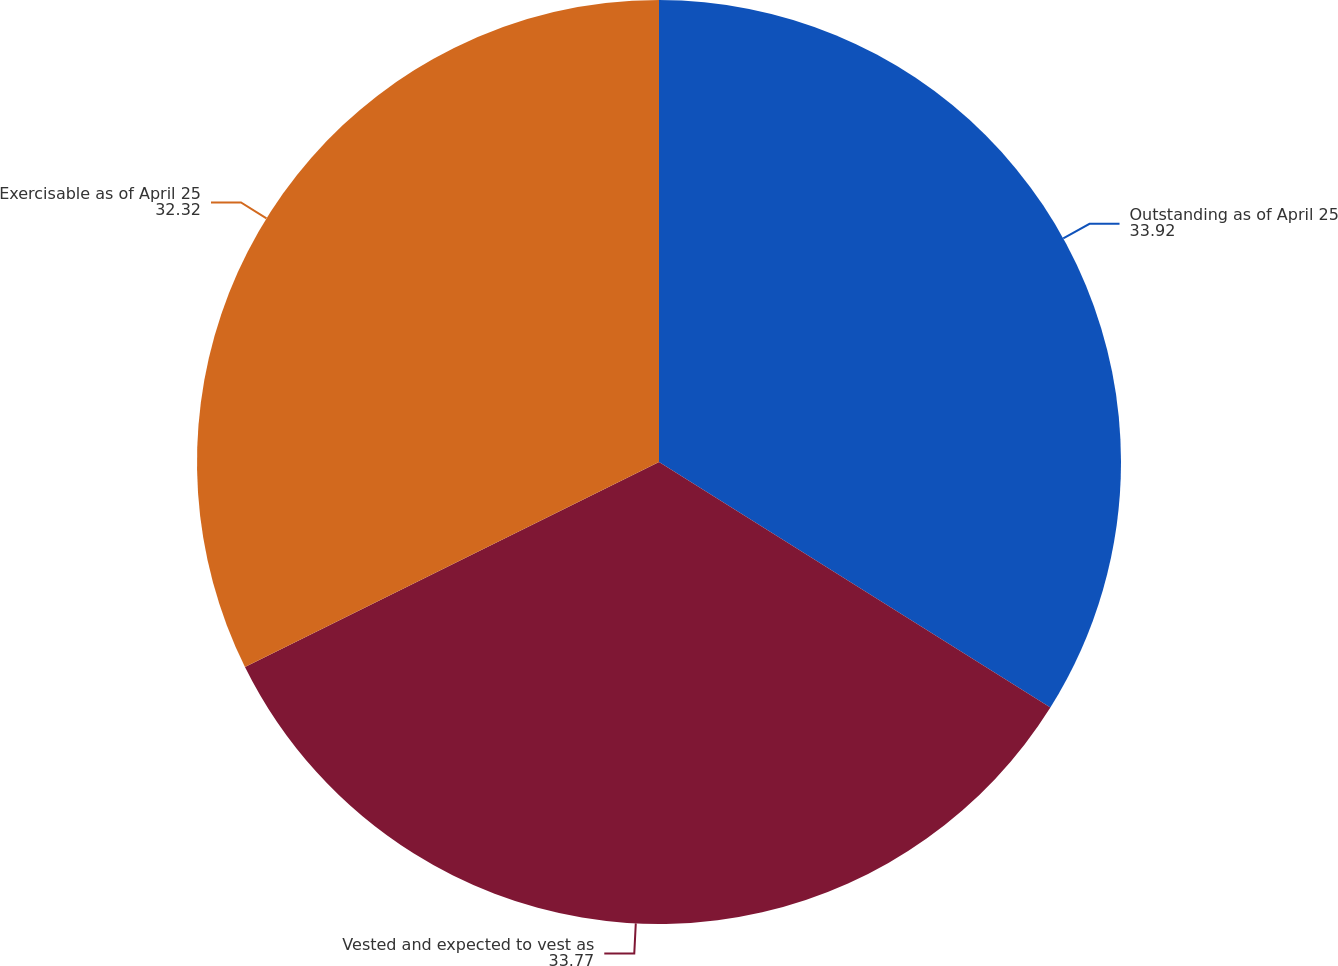Convert chart to OTSL. <chart><loc_0><loc_0><loc_500><loc_500><pie_chart><fcel>Outstanding as of April 25<fcel>Vested and expected to vest as<fcel>Exercisable as of April 25<nl><fcel>33.92%<fcel>33.77%<fcel>32.32%<nl></chart> 